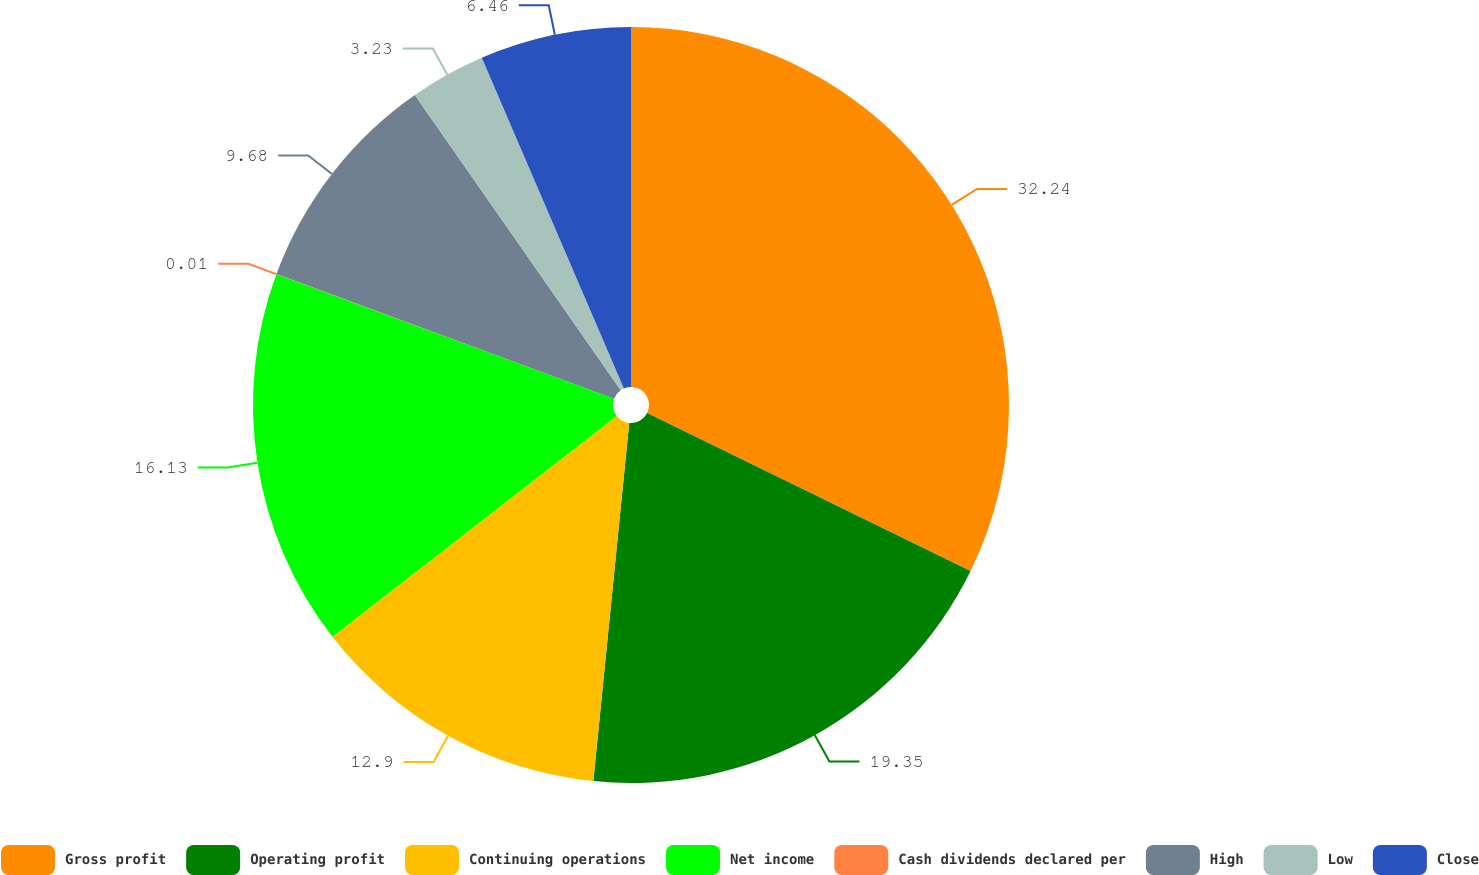Convert chart to OTSL. <chart><loc_0><loc_0><loc_500><loc_500><pie_chart><fcel>Gross profit<fcel>Operating profit<fcel>Continuing operations<fcel>Net income<fcel>Cash dividends declared per<fcel>High<fcel>Low<fcel>Close<nl><fcel>32.24%<fcel>19.35%<fcel>12.9%<fcel>16.13%<fcel>0.01%<fcel>9.68%<fcel>3.23%<fcel>6.46%<nl></chart> 